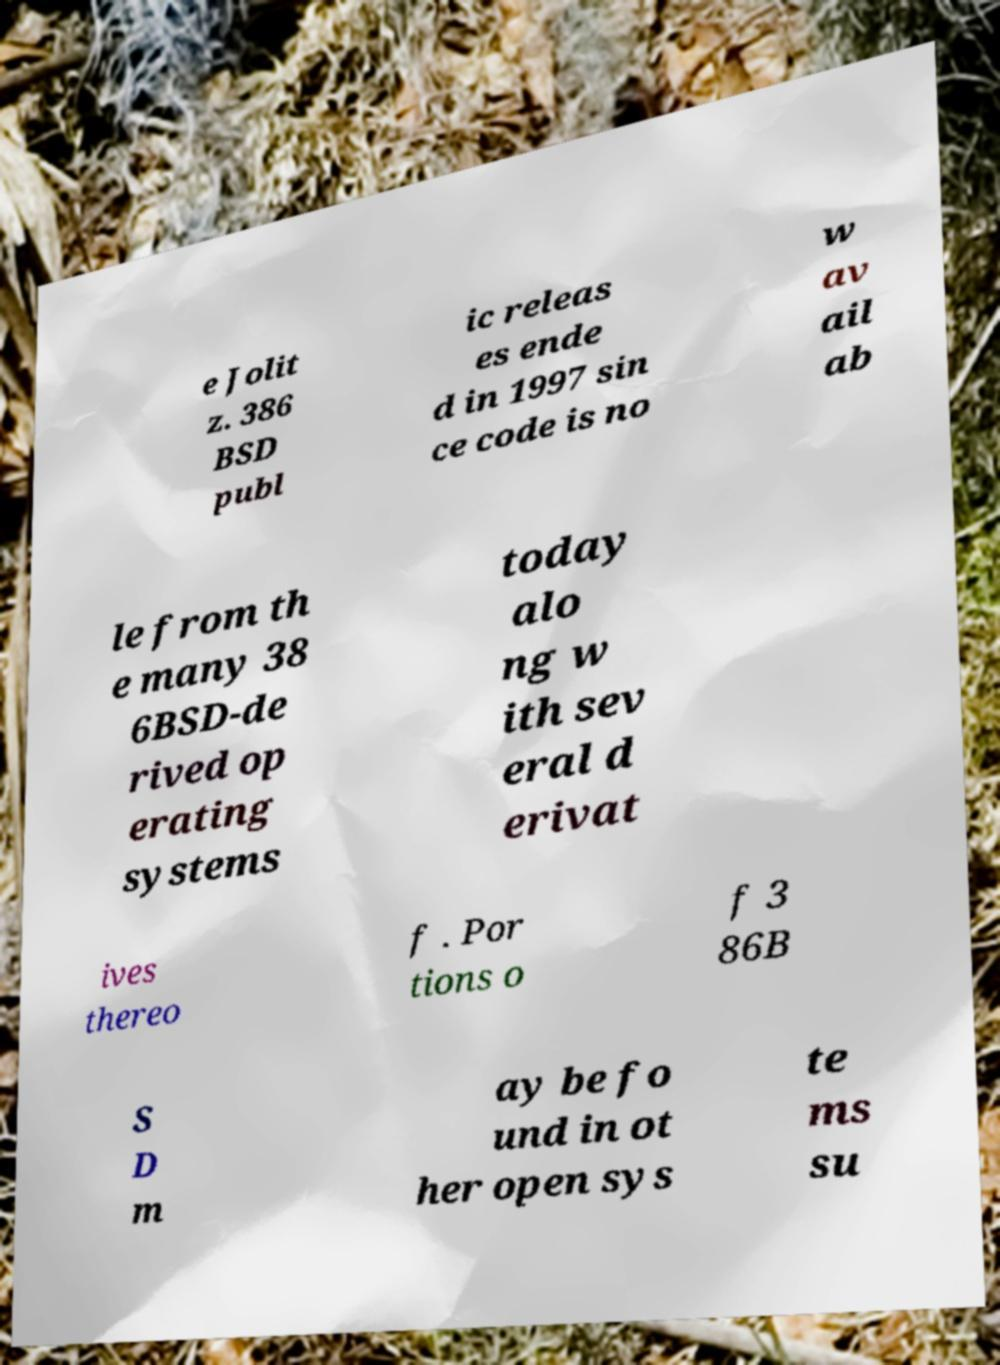Could you assist in decoding the text presented in this image and type it out clearly? e Jolit z. 386 BSD publ ic releas es ende d in 1997 sin ce code is no w av ail ab le from th e many 38 6BSD-de rived op erating systems today alo ng w ith sev eral d erivat ives thereo f . Por tions o f 3 86B S D m ay be fo und in ot her open sys te ms su 